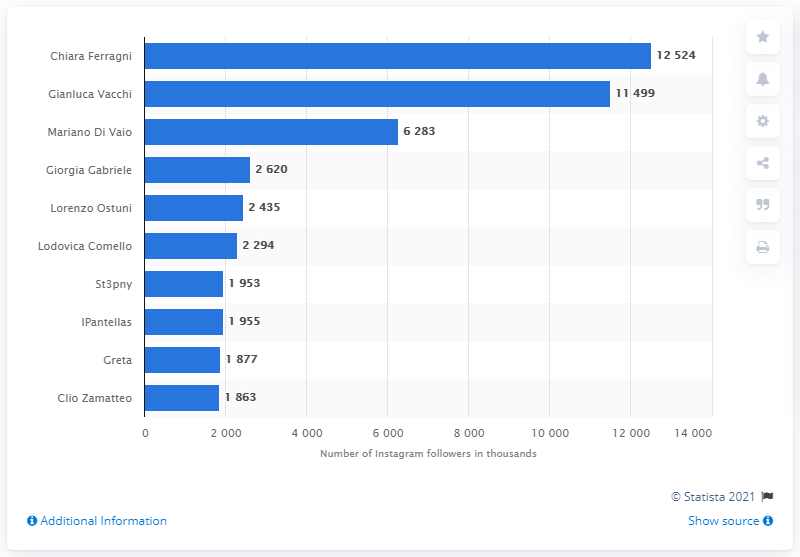Give some essential details in this illustration. Chiara Ferragni has the highest number of followers on Instagram. 